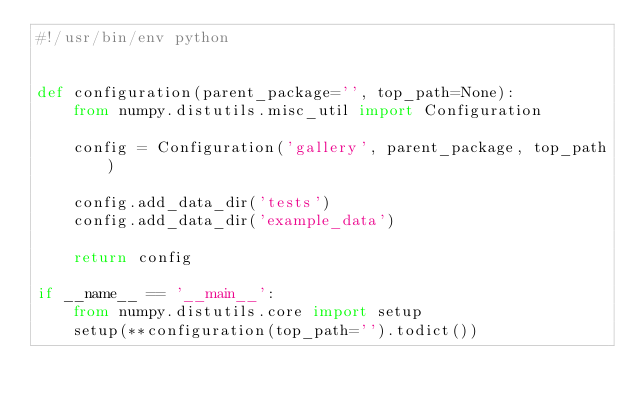<code> <loc_0><loc_0><loc_500><loc_500><_Python_>#!/usr/bin/env python


def configuration(parent_package='', top_path=None):
    from numpy.distutils.misc_util import Configuration

    config = Configuration('gallery', parent_package, top_path)

    config.add_data_dir('tests')
    config.add_data_dir('example_data')

    return config

if __name__ == '__main__':
    from numpy.distutils.core import setup
    setup(**configuration(top_path='').todict())
</code> 